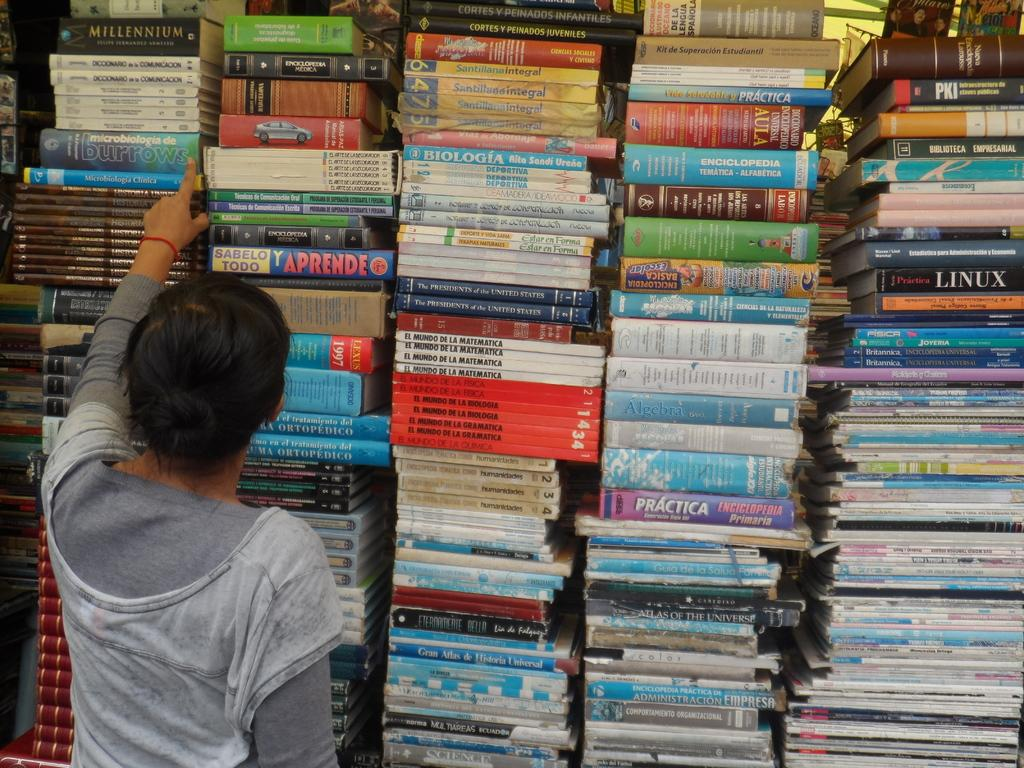Provide a one-sentence caption for the provided image. A woman looks through a wall of books with titles like Aprende and Practica. 